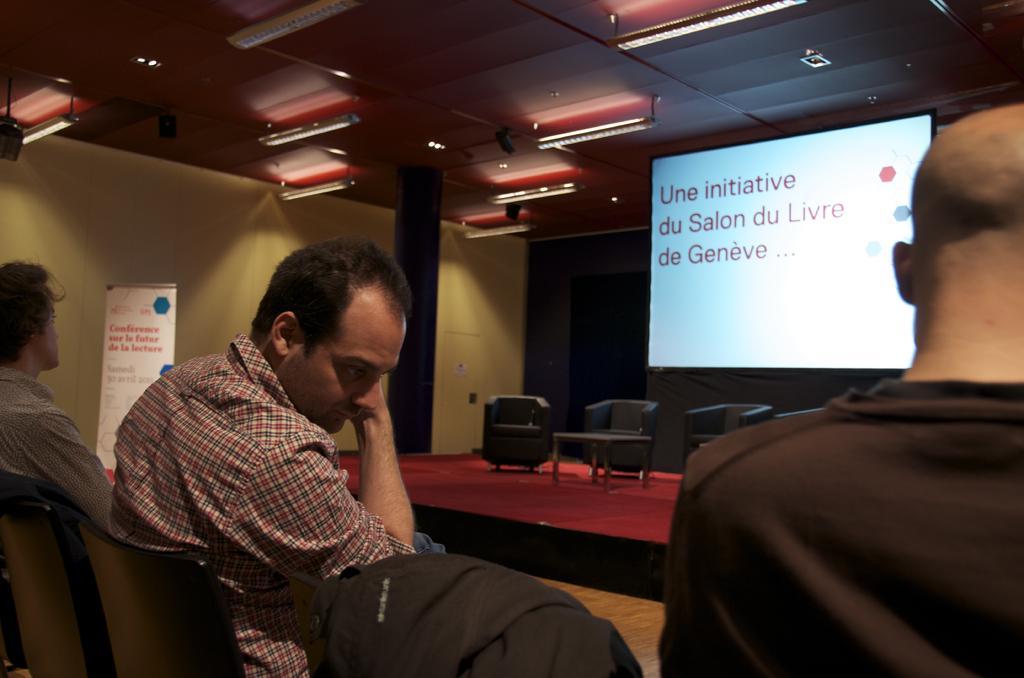In one or two sentences, can you explain what this image depicts? In this image we can see persons sitting on the chairs. In the background we can see dais, chairs, tables, screen, pillar, wall and lights. 